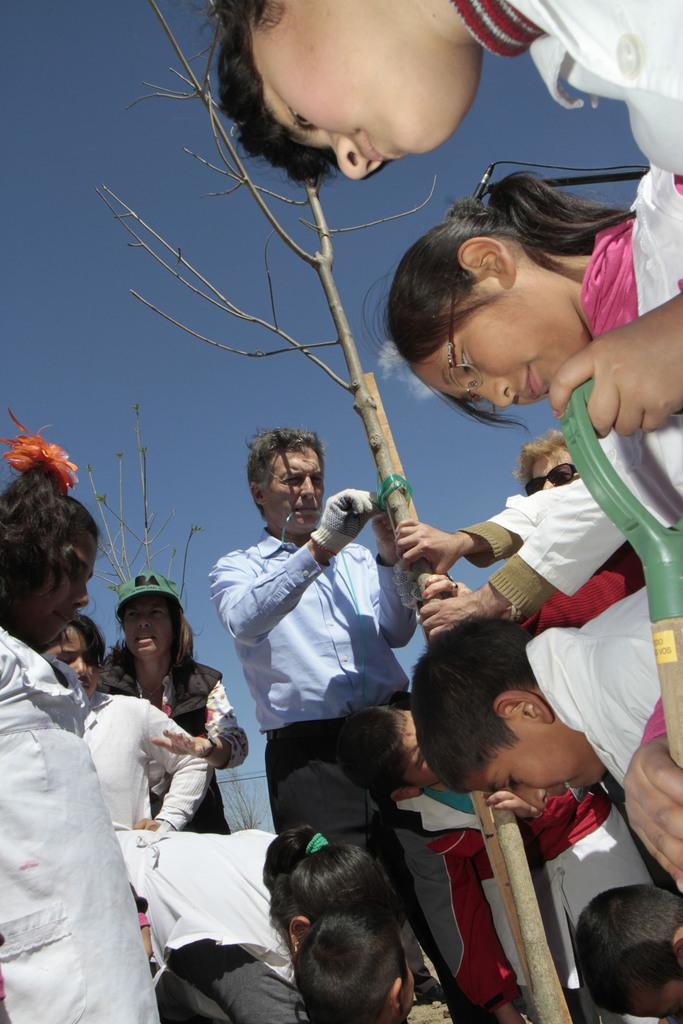How many people are in the image? There is a group of persons in the image. What is one person doing in the image? One person is holding a tree in the center of the image. What can be seen in the background of the image? There is a sky visible in the background of the image. What is the condition of the sky in the image? Clouds are present in the sky. What type of zephyr can be seen blowing the tree in the image? There is no zephyr present in the image, and the tree is being held by a person, not blown by the wind. What business is being conducted by the group of persons in the image? The image does not depict any business activities; it simply shows a group of persons with one person holding a tree. 